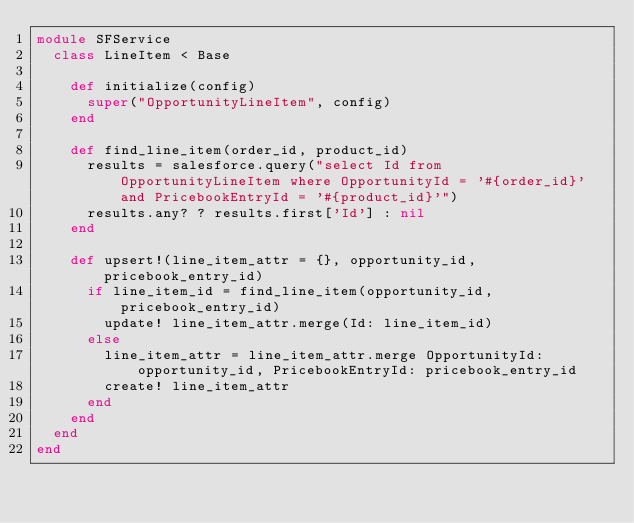<code> <loc_0><loc_0><loc_500><loc_500><_Ruby_>module SFService
  class LineItem < Base

    def initialize(config)
      super("OpportunityLineItem", config)
    end

    def find_line_item(order_id, product_id)
      results = salesforce.query("select Id from OpportunityLineItem where OpportunityId = '#{order_id}' and PricebookEntryId = '#{product_id}'")
      results.any? ? results.first['Id'] : nil
    end

    def upsert!(line_item_attr = {}, opportunity_id, pricebook_entry_id)
      if line_item_id = find_line_item(opportunity_id, pricebook_entry_id)
        update! line_item_attr.merge(Id: line_item_id)
      else
        line_item_attr = line_item_attr.merge OpportunityId: opportunity_id, PricebookEntryId: pricebook_entry_id
        create! line_item_attr
      end
    end
  end
end
</code> 